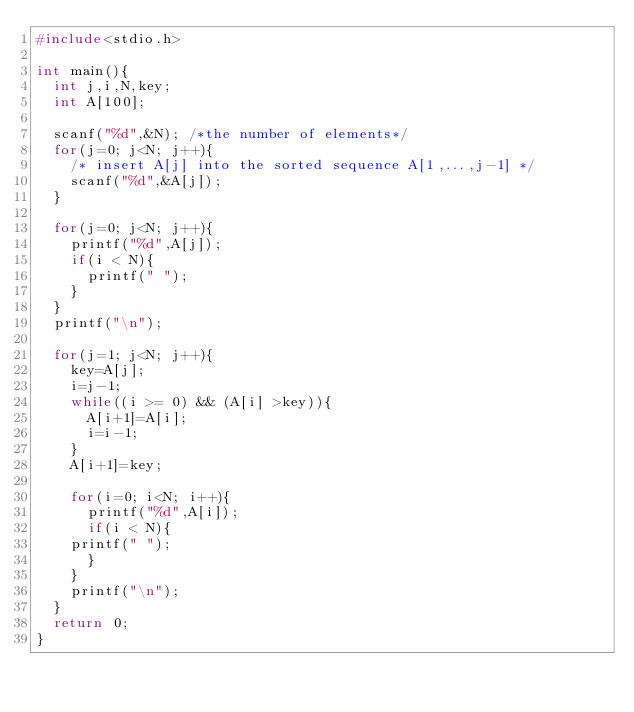Convert code to text. <code><loc_0><loc_0><loc_500><loc_500><_C_>#include<stdio.h> 

int main(){
  int j,i,N,key;
  int A[100];

  scanf("%d",&N); /*the number of elements*/
  for(j=0; j<N; j++){
    /* insert A[j] into the sorted sequence A[1,...,j-1] */
    scanf("%d",&A[j]);
  }
  
  for(j=0; j<N; j++){
    printf("%d",A[j]);
    if(i < N){
      printf(" ");
    }
  }
  printf("\n");

  for(j=1; j<N; j++){
    key=A[j];
    i=j-1;
    while((i >= 0) && (A[i] >key)){
      A[i+1]=A[i];
      i=i-1;
    }  
    A[i+1]=key;
    
    for(i=0; i<N; i++){
      printf("%d",A[i]);
      if(i < N){
	printf(" ");
      }
    }
    printf("\n");
  }
  return 0;
}</code> 